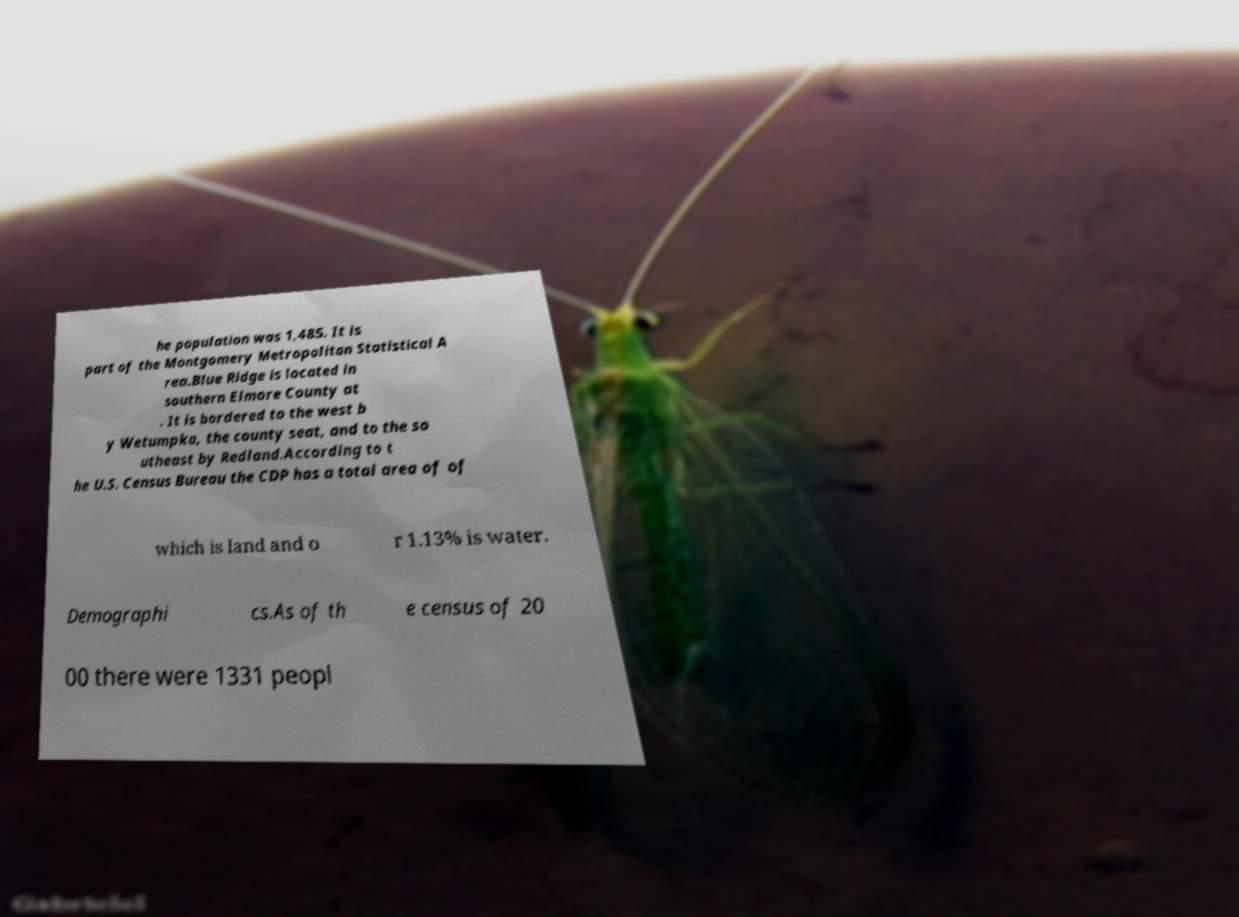There's text embedded in this image that I need extracted. Can you transcribe it verbatim? he population was 1,485. It is part of the Montgomery Metropolitan Statistical A rea.Blue Ridge is located in southern Elmore County at . It is bordered to the west b y Wetumpka, the county seat, and to the so utheast by Redland.According to t he U.S. Census Bureau the CDP has a total area of of which is land and o r 1.13% is water. Demographi cs.As of th e census of 20 00 there were 1331 peopl 